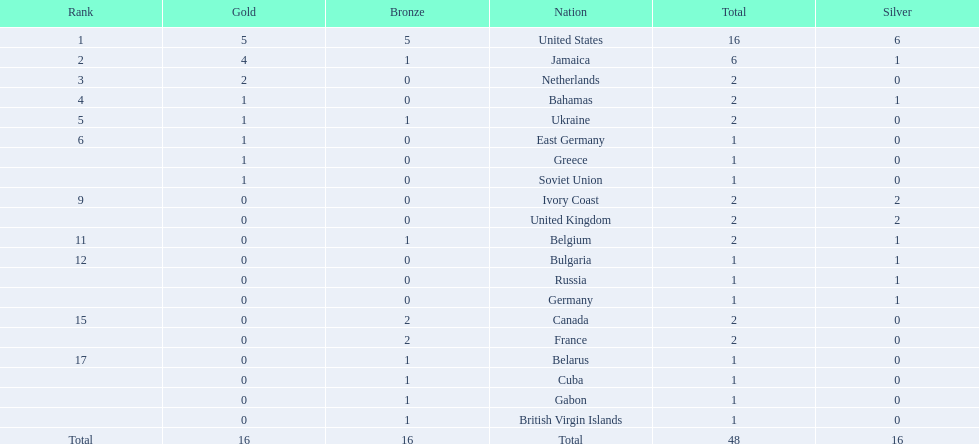What countries competed? United States, Jamaica, Netherlands, Bahamas, Ukraine, East Germany, Greece, Soviet Union, Ivory Coast, United Kingdom, Belgium, Bulgaria, Russia, Germany, Canada, France, Belarus, Cuba, Gabon, British Virgin Islands. Which countries won gold medals? United States, Jamaica, Netherlands, Bahamas, Ukraine, East Germany, Greece, Soviet Union. Which country had the second most medals? Jamaica. Would you be able to parse every entry in this table? {'header': ['Rank', 'Gold', 'Bronze', 'Nation', 'Total', 'Silver'], 'rows': [['1', '5', '5', 'United States', '16', '6'], ['2', '4', '1', 'Jamaica', '6', '1'], ['3', '2', '0', 'Netherlands', '2', '0'], ['4', '1', '0', 'Bahamas', '2', '1'], ['5', '1', '1', 'Ukraine', '2', '0'], ['6', '1', '0', 'East Germany', '1', '0'], ['', '1', '0', 'Greece', '1', '0'], ['', '1', '0', 'Soviet Union', '1', '0'], ['9', '0', '0', 'Ivory Coast', '2', '2'], ['', '0', '0', 'United Kingdom', '2', '2'], ['11', '0', '1', 'Belgium', '2', '1'], ['12', '0', '0', 'Bulgaria', '1', '1'], ['', '0', '0', 'Russia', '1', '1'], ['', '0', '0', 'Germany', '1', '1'], ['15', '0', '2', 'Canada', '2', '0'], ['', '0', '2', 'France', '2', '0'], ['17', '0', '1', 'Belarus', '1', '0'], ['', '0', '1', 'Cuba', '1', '0'], ['', '0', '1', 'Gabon', '1', '0'], ['', '0', '1', 'British Virgin Islands', '1', '0'], ['Total', '16', '16', 'Total', '48', '16']]} 